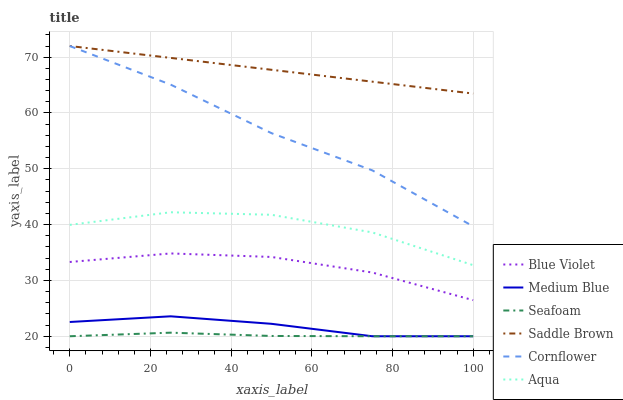Does Seafoam have the minimum area under the curve?
Answer yes or no. Yes. Does Saddle Brown have the maximum area under the curve?
Answer yes or no. Yes. Does Medium Blue have the minimum area under the curve?
Answer yes or no. No. Does Medium Blue have the maximum area under the curve?
Answer yes or no. No. Is Saddle Brown the smoothest?
Answer yes or no. Yes. Is Aqua the roughest?
Answer yes or no. Yes. Is Medium Blue the smoothest?
Answer yes or no. No. Is Medium Blue the roughest?
Answer yes or no. No. Does Aqua have the lowest value?
Answer yes or no. No. Does Saddle Brown have the highest value?
Answer yes or no. Yes. Does Medium Blue have the highest value?
Answer yes or no. No. Is Medium Blue less than Blue Violet?
Answer yes or no. Yes. Is Cornflower greater than Aqua?
Answer yes or no. Yes. Does Saddle Brown intersect Cornflower?
Answer yes or no. Yes. Is Saddle Brown less than Cornflower?
Answer yes or no. No. Is Saddle Brown greater than Cornflower?
Answer yes or no. No. Does Medium Blue intersect Blue Violet?
Answer yes or no. No. 